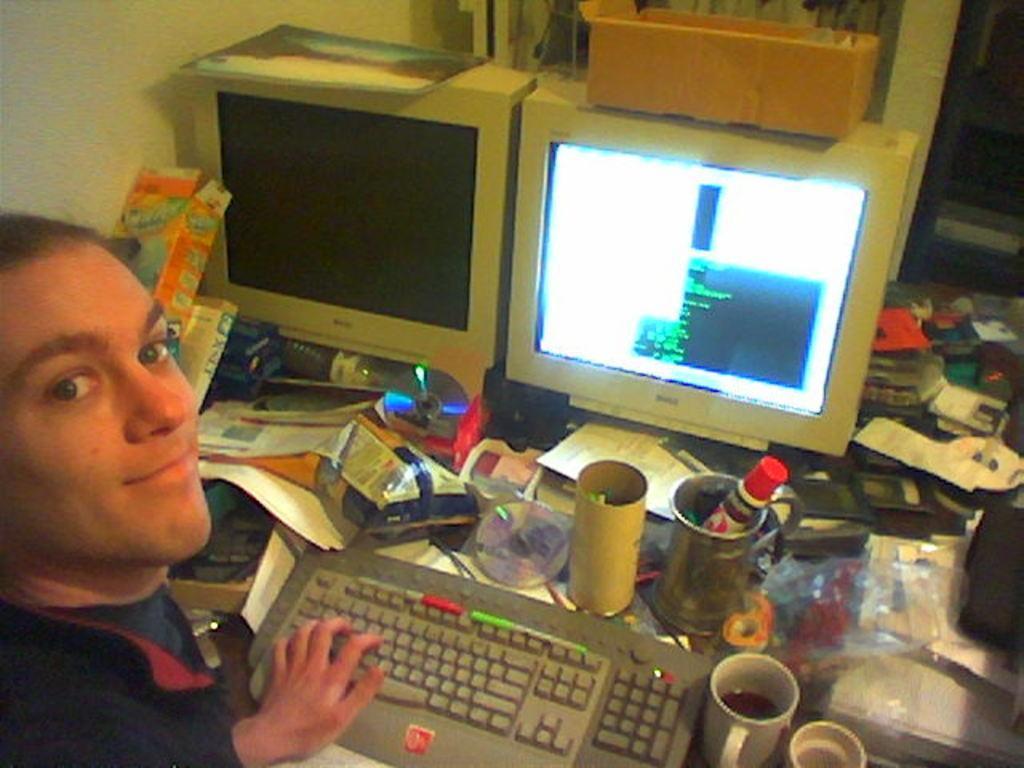In one or two sentences, can you explain what this image depicts? There is a person in the left corner and there are two desktops,keyboards,cups and some other objects placed in front of him on a table. 